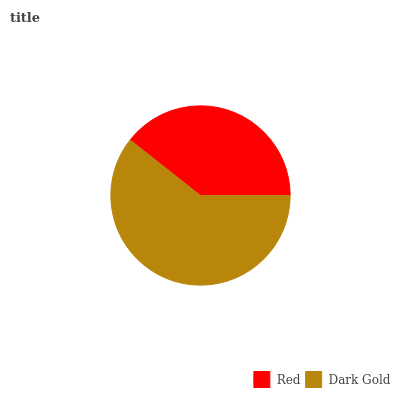Is Red the minimum?
Answer yes or no. Yes. Is Dark Gold the maximum?
Answer yes or no. Yes. Is Dark Gold the minimum?
Answer yes or no. No. Is Dark Gold greater than Red?
Answer yes or no. Yes. Is Red less than Dark Gold?
Answer yes or no. Yes. Is Red greater than Dark Gold?
Answer yes or no. No. Is Dark Gold less than Red?
Answer yes or no. No. Is Dark Gold the high median?
Answer yes or no. Yes. Is Red the low median?
Answer yes or no. Yes. Is Red the high median?
Answer yes or no. No. Is Dark Gold the low median?
Answer yes or no. No. 